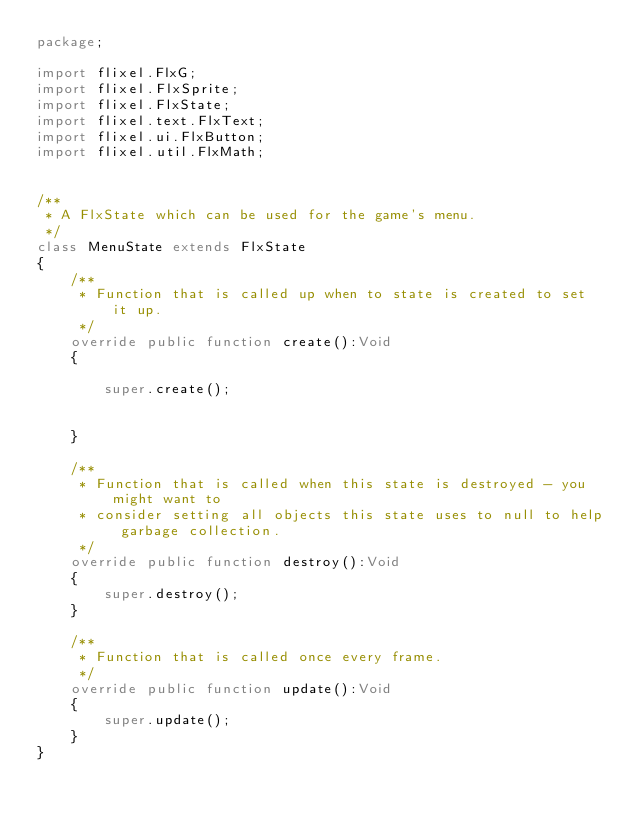Convert code to text. <code><loc_0><loc_0><loc_500><loc_500><_Haxe_>package;

import flixel.FlxG;
import flixel.FlxSprite;
import flixel.FlxState;
import flixel.text.FlxText;
import flixel.ui.FlxButton;
import flixel.util.FlxMath;


/**
 * A FlxState which can be used for the game's menu.
 */
class MenuState extends FlxState
{
	/**
	 * Function that is called up when to state is created to set it up. 
	 */
	override public function create():Void
	{

		super.create();


	}
	
	/**
	 * Function that is called when this state is destroyed - you might want to 
	 * consider setting all objects this state uses to null to help garbage collection.
	 */
	override public function destroy():Void
	{
		super.destroy();
	}

	/**
	 * Function that is called once every frame.
	 */
	override public function update():Void
	{
		super.update();
	}	
}</code> 